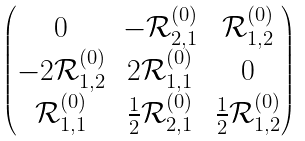Convert formula to latex. <formula><loc_0><loc_0><loc_500><loc_500>\begin{pmatrix} 0 & - \mathcal { R } ^ { ( 0 ) } _ { 2 , 1 } & \mathcal { R } ^ { ( 0 ) } _ { 1 , 2 } \\ - 2 \mathcal { R } ^ { ( 0 ) } _ { 1 , 2 } & 2 \mathcal { R } ^ { ( 0 ) } _ { 1 , 1 } & 0 \\ \mathcal { R } ^ { ( 0 ) } _ { 1 , 1 } & \frac { 1 } { 2 } \mathcal { R } ^ { ( 0 ) } _ { 2 , 1 } & \frac { 1 } { 2 } \mathcal { R } ^ { ( 0 ) } _ { 1 , 2 } \end{pmatrix}</formula> 